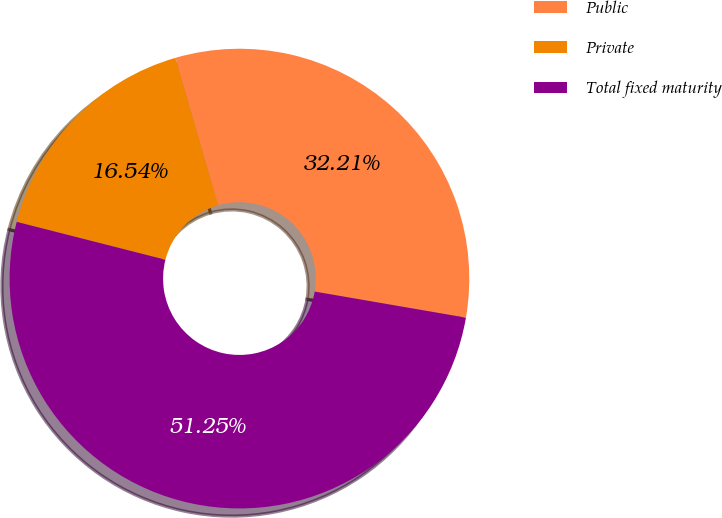<chart> <loc_0><loc_0><loc_500><loc_500><pie_chart><fcel>Public<fcel>Private<fcel>Total fixed maturity<nl><fcel>32.21%<fcel>16.54%<fcel>51.25%<nl></chart> 